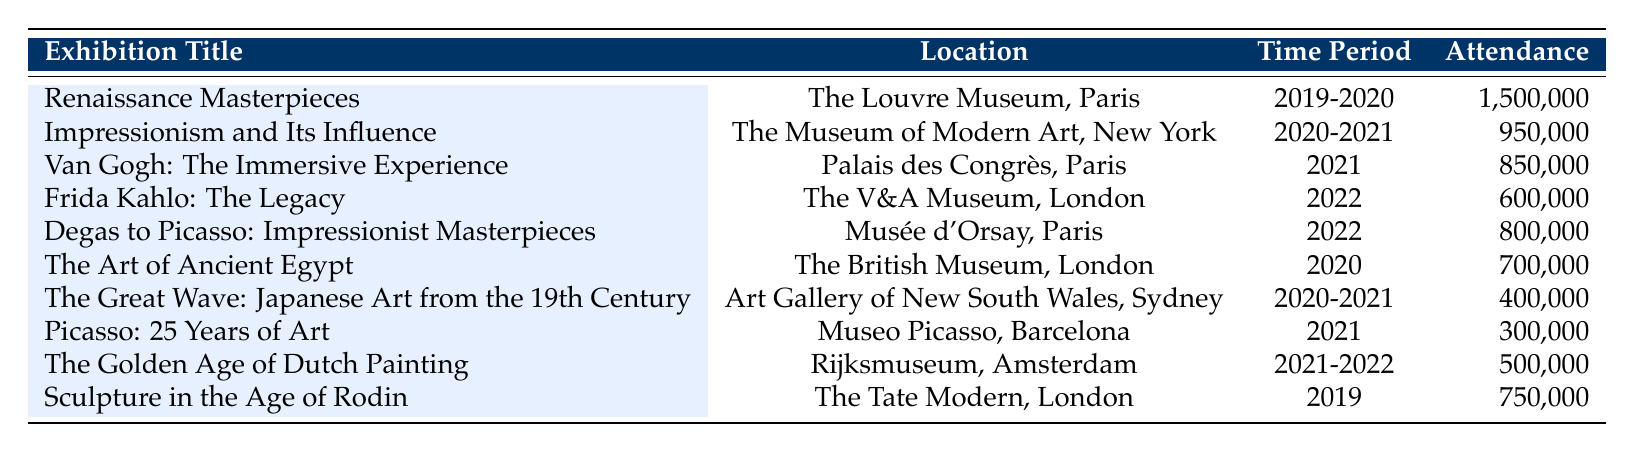What was the attendance of the "Renaissance Masterpieces" exhibition? The table shows that the attendance for "Renaissance Masterpieces" at The Louvre Museum, Paris in the time period of 2019-2020 was 1,500,000.
Answer: 1,500,000 Which exhibition had the highest attendance? The "Renaissance Masterpieces" exhibition at The Louvre Museum, Paris had the highest attendance of 1,500,000, which is clearly indicated in the attendance column.
Answer: Renaissance Masterpieces How many exhibitions had attendance figures of over 800,000? By scanning the attendance figures, we see that "Renaissance Masterpieces," "Impressionism and Its Influence," and "Van Gogh: The Immersive Experience" each had over 800,000 attendees. This makes a total of three exhibitions.
Answer: 3 What is the average attendance of the exhibitions held in 2021? The exhibitions in 2021 are "Van Gogh: The Immersive Experience" (850,000), "Picasso: 25 Years of Art" (300,000), and "The Golden Age of Dutch Painting" (500,000). Their total attendance is 850,000 + 300,000 + 500,000 = 1,650,000. There are 3 exhibitions, so the average attendance is 1,650,000 / 3 = 550,000.
Answer: 550,000 Was the attendance of "The Art of Ancient Egypt" higher than 600,000? The table states that the attendance for "The Art of Ancient Egypt" was 700,000, which is indeed higher than 600,000.
Answer: Yes Which location had the least number of attendees in its exhibitions? Looking through the table, "Museo Picasso, Barcelona" had the least number of attendees at 300,000, the lowest figure listed in the table.
Answer: Museo Picasso, Barcelona How many exhibitions took place in London? The exhibitions in London are "Frida Kahlo: The Legacy" and "Sculpture in the Age of Rodin," totaling 2 exhibitions.
Answer: 2 Between the exhibitions in Paris and London, which location had a higher total attendance? In Paris, "Renaissance Masterpieces" (1,500,000) and "Van Gogh: The Immersive Experience" (850,000) bring the total to 2,350,000. In London, "Frida Kahlo: The Legacy" (600,000) and "Sculpture in the Age of Rodin" (750,000) sum to 1,350,000. Since 2,350,000 (Paris) is greater than 1,350,000 (London), Paris had the higher attendance overall.
Answer: Paris What is the total attendance of exhibitions held in 2022? The exhibitions held in 2022 are "Frida Kahlo: The Legacy" (600,000) and "Degas to Picasso: Impressionist Masterpieces" (800,000). Adding these gives 600,000 + 800,000 = 1,400,000 for total attendance in that year.
Answer: 1,400,000 Did the "Great Wave" exhibition occur in the same period as "Impressionism and Its Influence"? "The Great Wave" exhibition was held in the time period of 2020-2021 and "Impressionism and Its Influence" was held in 2020-2021 as well. Therefore, they did occur in the same period.
Answer: Yes 